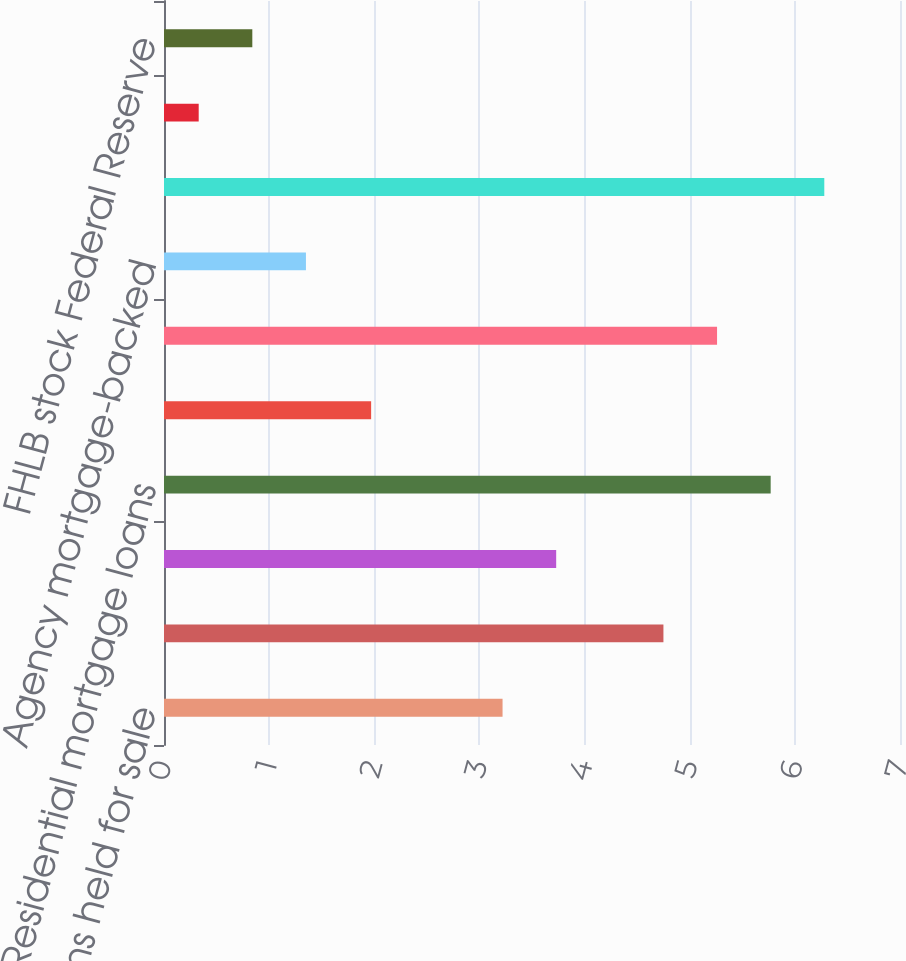Convert chart to OTSL. <chart><loc_0><loc_0><loc_500><loc_500><bar_chart><fcel>Loans held for sale<fcel>C&I loans<fcel>CRE loans<fcel>Residential mortgage loans<fcel>Consumer loans<fcel>Total loans net<fcel>Agency mortgage-backed<fcel>Non-agency CMOs<fcel>Money market funds cash and<fcel>FHLB stock Federal Reserve<nl><fcel>3.22<fcel>4.75<fcel>3.73<fcel>5.77<fcel>1.97<fcel>5.26<fcel>1.35<fcel>6.28<fcel>0.33<fcel>0.84<nl></chart> 